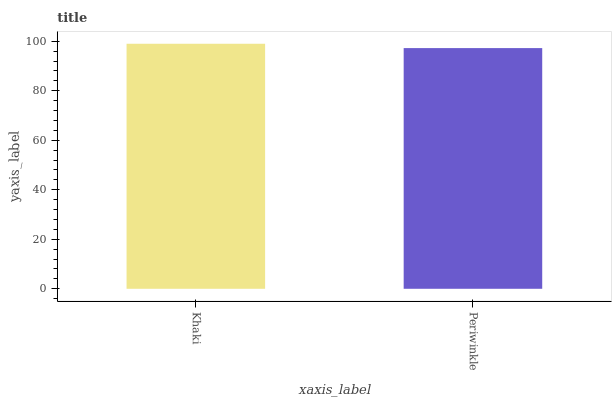Is Periwinkle the minimum?
Answer yes or no. Yes. Is Khaki the maximum?
Answer yes or no. Yes. Is Periwinkle the maximum?
Answer yes or no. No. Is Khaki greater than Periwinkle?
Answer yes or no. Yes. Is Periwinkle less than Khaki?
Answer yes or no. Yes. Is Periwinkle greater than Khaki?
Answer yes or no. No. Is Khaki less than Periwinkle?
Answer yes or no. No. Is Khaki the high median?
Answer yes or no. Yes. Is Periwinkle the low median?
Answer yes or no. Yes. Is Periwinkle the high median?
Answer yes or no. No. Is Khaki the low median?
Answer yes or no. No. 